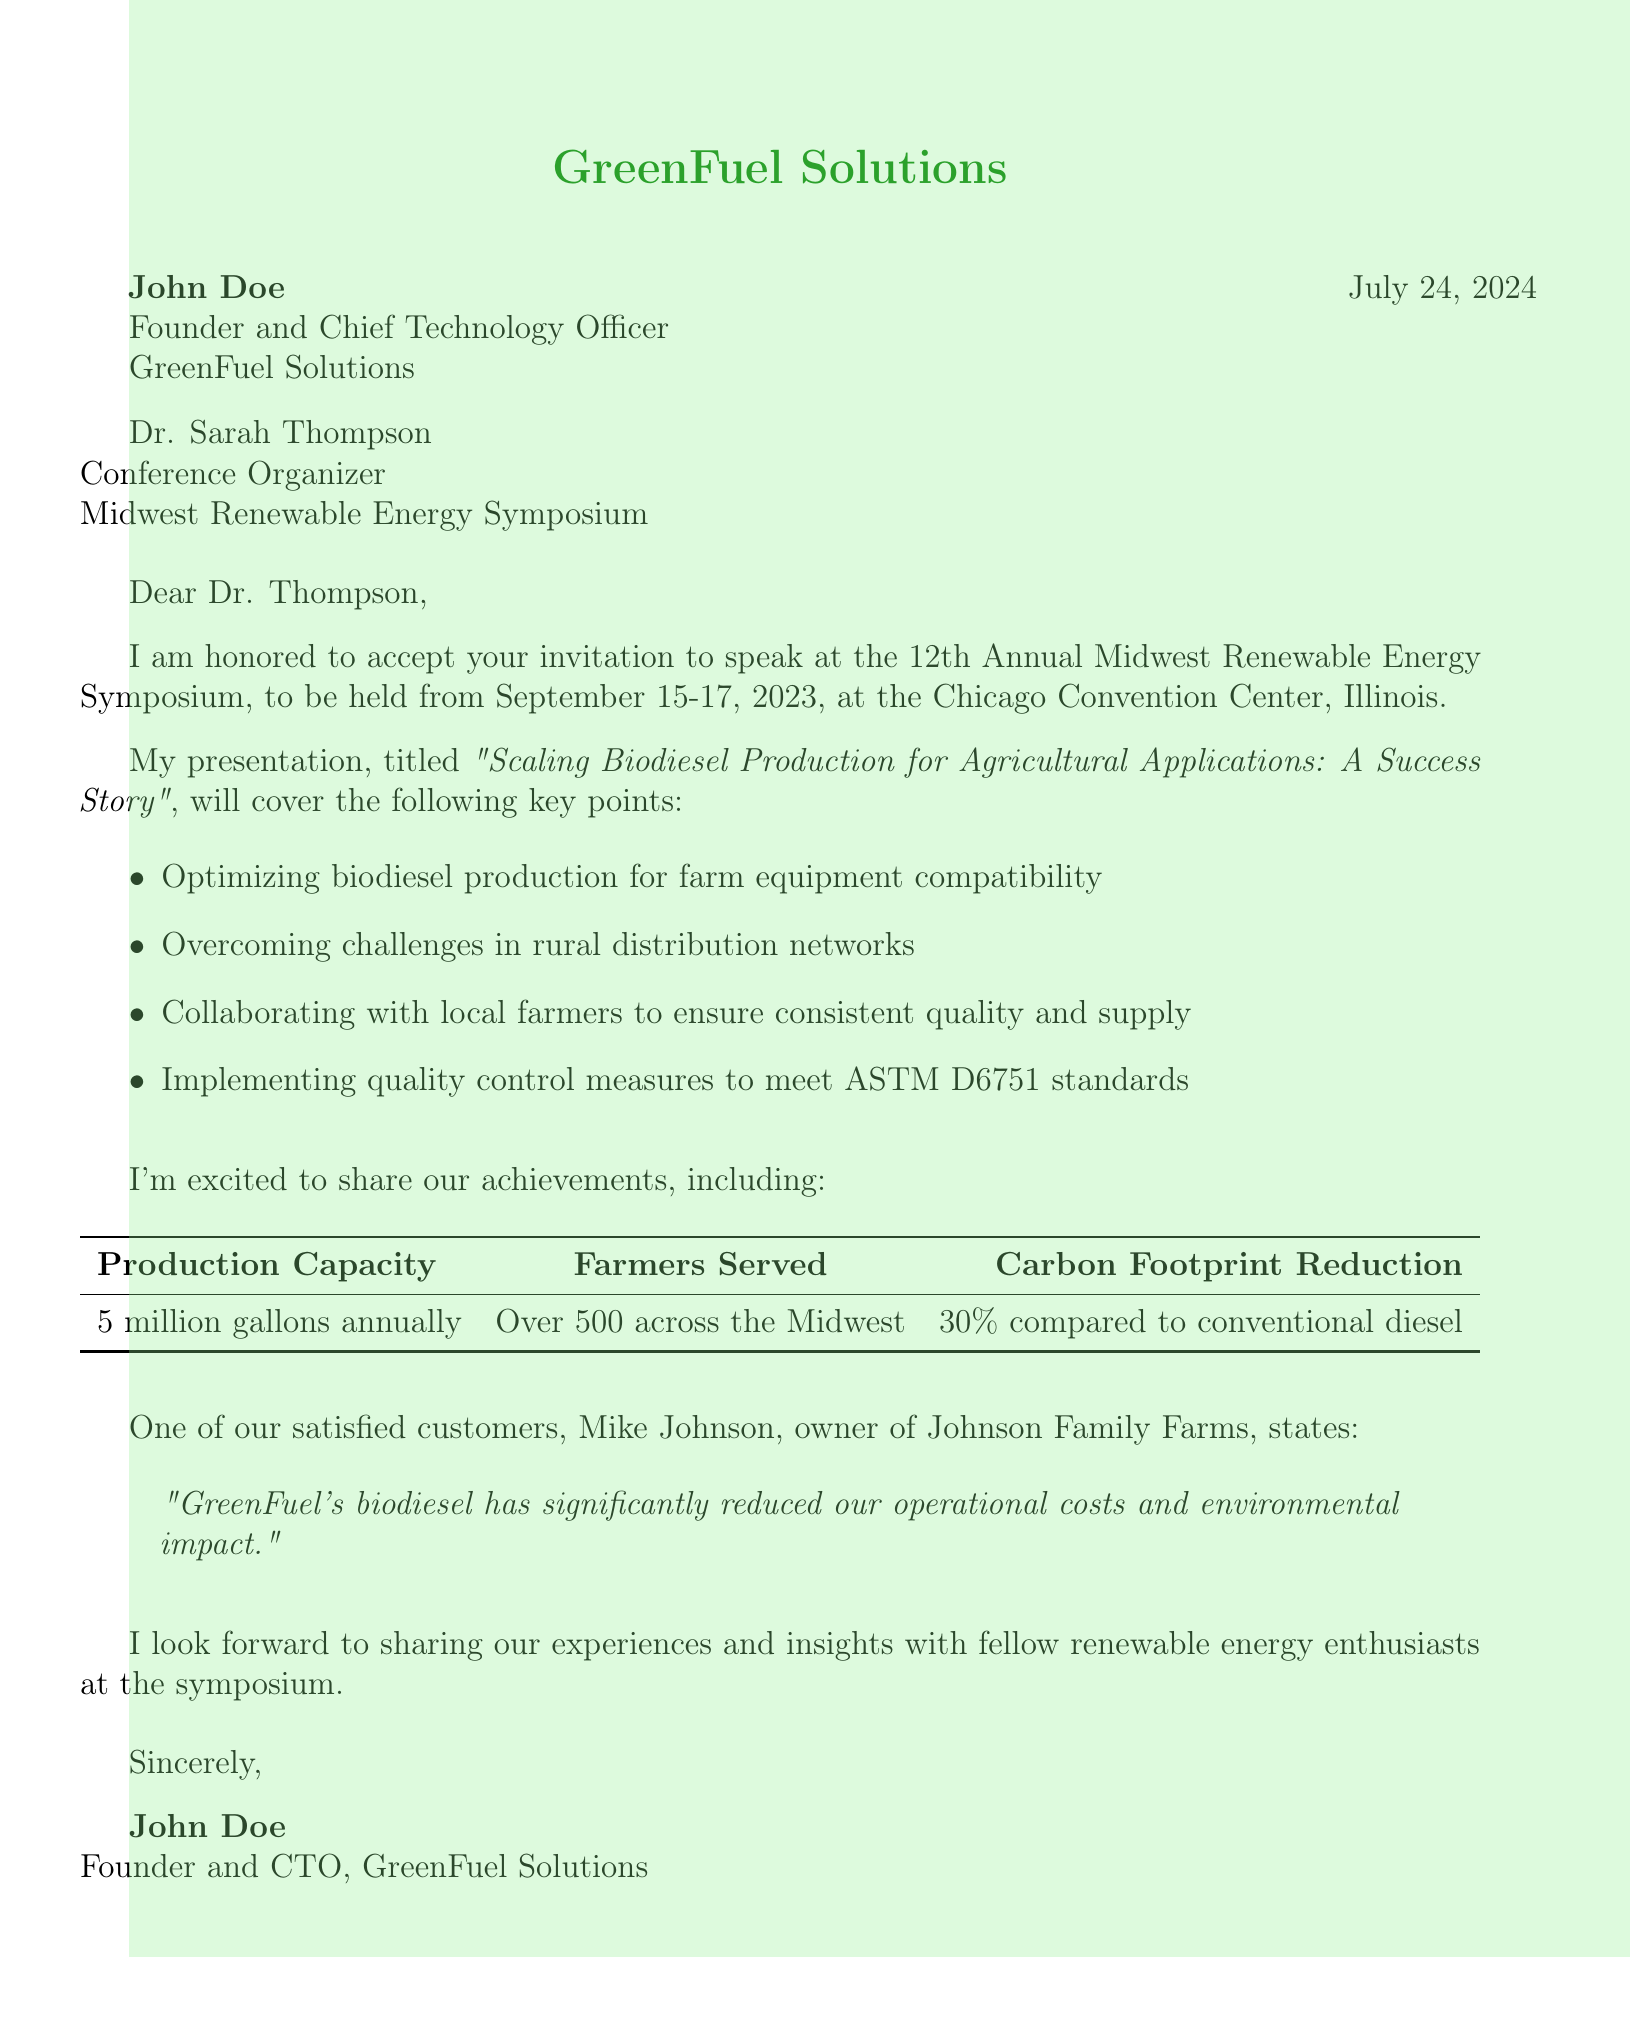What is the name of the conference? The document mentions the event as the "12th Annual Midwest Renewable Energy Symposium."
Answer: 12th Annual Midwest Renewable Energy Symposium Who is the speaker at the conference? The document states that the speaker is John Doe.
Answer: John Doe What is the production capacity of GreenFuel Solutions? The document specifies the production capacity as "5 million gallons annually."
Answer: 5 million gallons annually Which standards does GreenFuel Solutions meet for quality control? The document indicates that they meet "ASTM D6751 standards."
Answer: ASTM D6751 standards How many farmers are served by GreenFuel Solutions? The document notes that they serve "Over 500 across the Midwest."
Answer: Over 500 across the Midwest What will be the main topic of the presentation? The document reveals that the main topic is "Scaling Biodiesel Production for Agricultural Applications: A Success Story."
Answer: Scaling Biodiesel Production for Agricultural Applications: A Success Story What is the carbon footprint reduction compared to conventional diesel? The document highlights that the carbon footprint reduction is "30% compared to conventional diesel."
Answer: 30% compared to conventional diesel Who provided a testimonial about GreenFuel Solutions? The document cites Mike Johnson as the person who provided a testimonial.
Answer: Mike Johnson What dates will the symposium take place? The document states the dates as "September 15-17, 2023."
Answer: September 15-17, 2023 